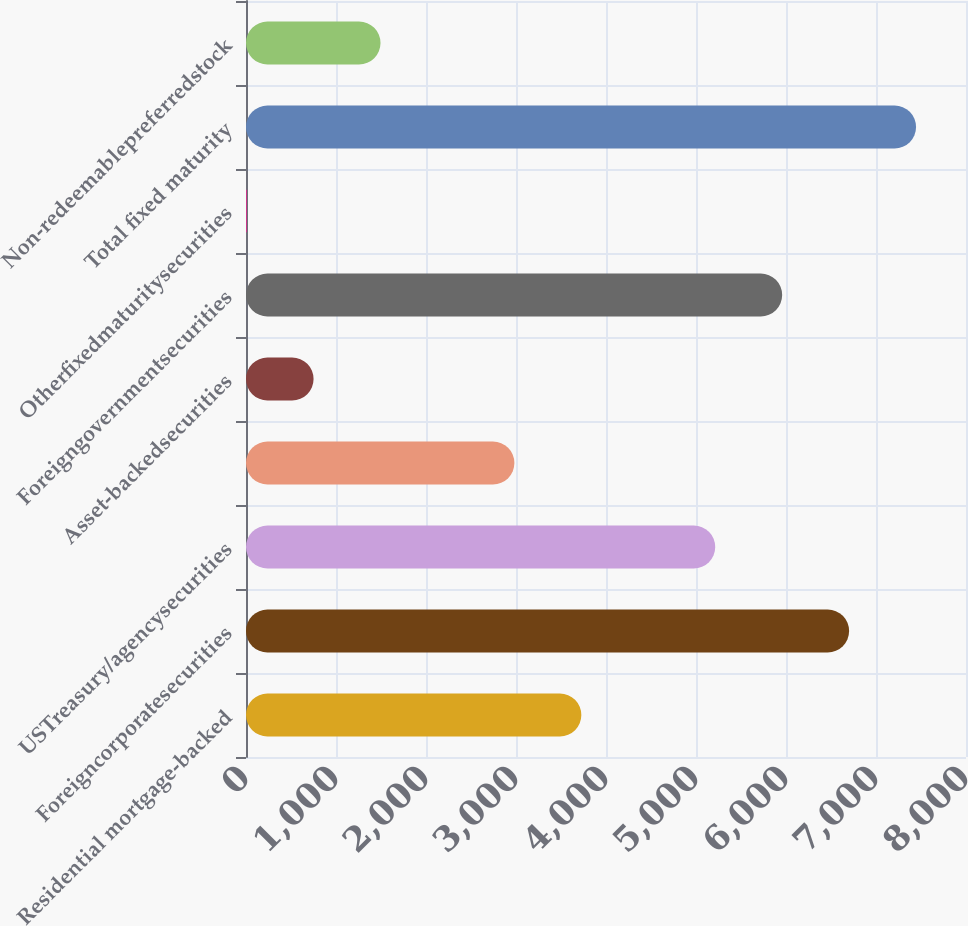<chart> <loc_0><loc_0><loc_500><loc_500><bar_chart><fcel>Residential mortgage-backed<fcel>Foreigncorporatesecurities<fcel>USTreasury/agencysecurities<fcel>Unnamed: 3<fcel>Asset-backedsecurities<fcel>Foreigngovernmentsecurities<fcel>Otherfixedmaturitysecurities<fcel>Total fixed maturity<fcel>Non-redeemablepreferredstock<nl><fcel>3726<fcel>6701.2<fcel>5213.6<fcel>2982.2<fcel>750.8<fcel>5957.4<fcel>7<fcel>7445<fcel>1494.6<nl></chart> 